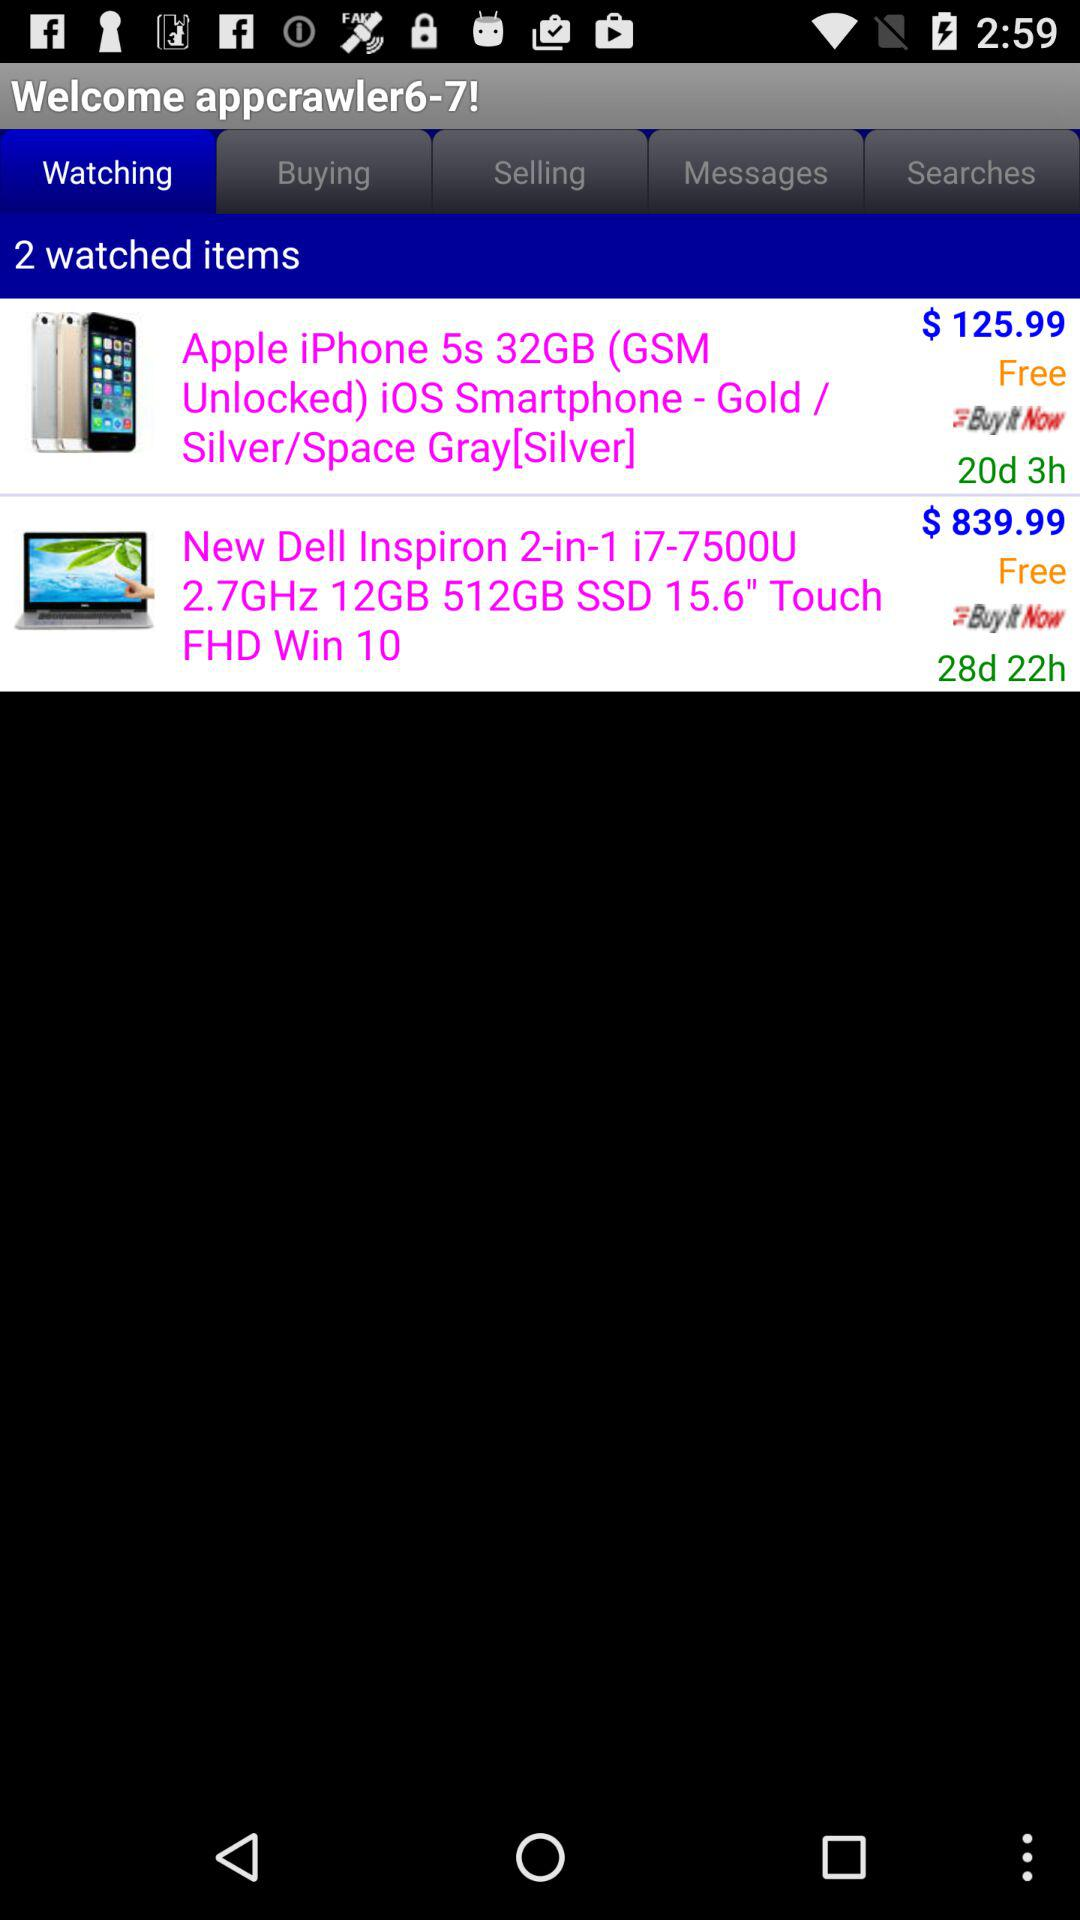The iPhone is delivered within how many days?
When the provided information is insufficient, respond with <no answer>. <no answer> 